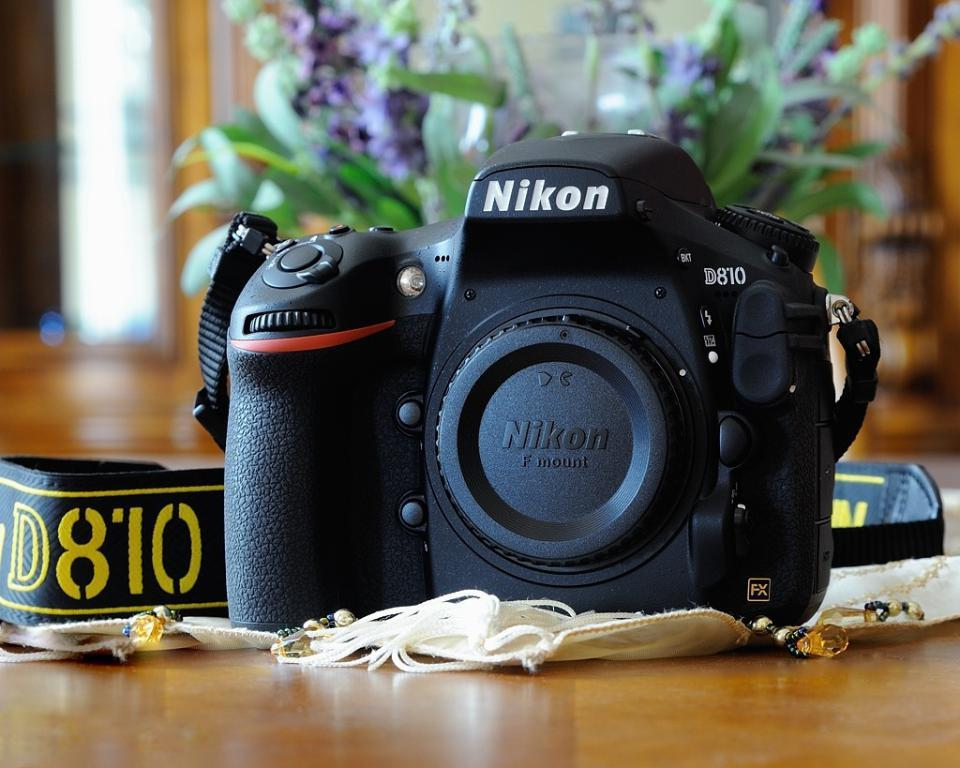What type of camera is in the image? There is a black color Nikon camera in the image. Where is the camera located in the image? The camera is on a surface. What can be seen in the background of the image? There is a flower vase in the background of the image. How many leaves are on the cat in the image? There is no cat present in the image, and therefore no leaves can be observed on a cat. 